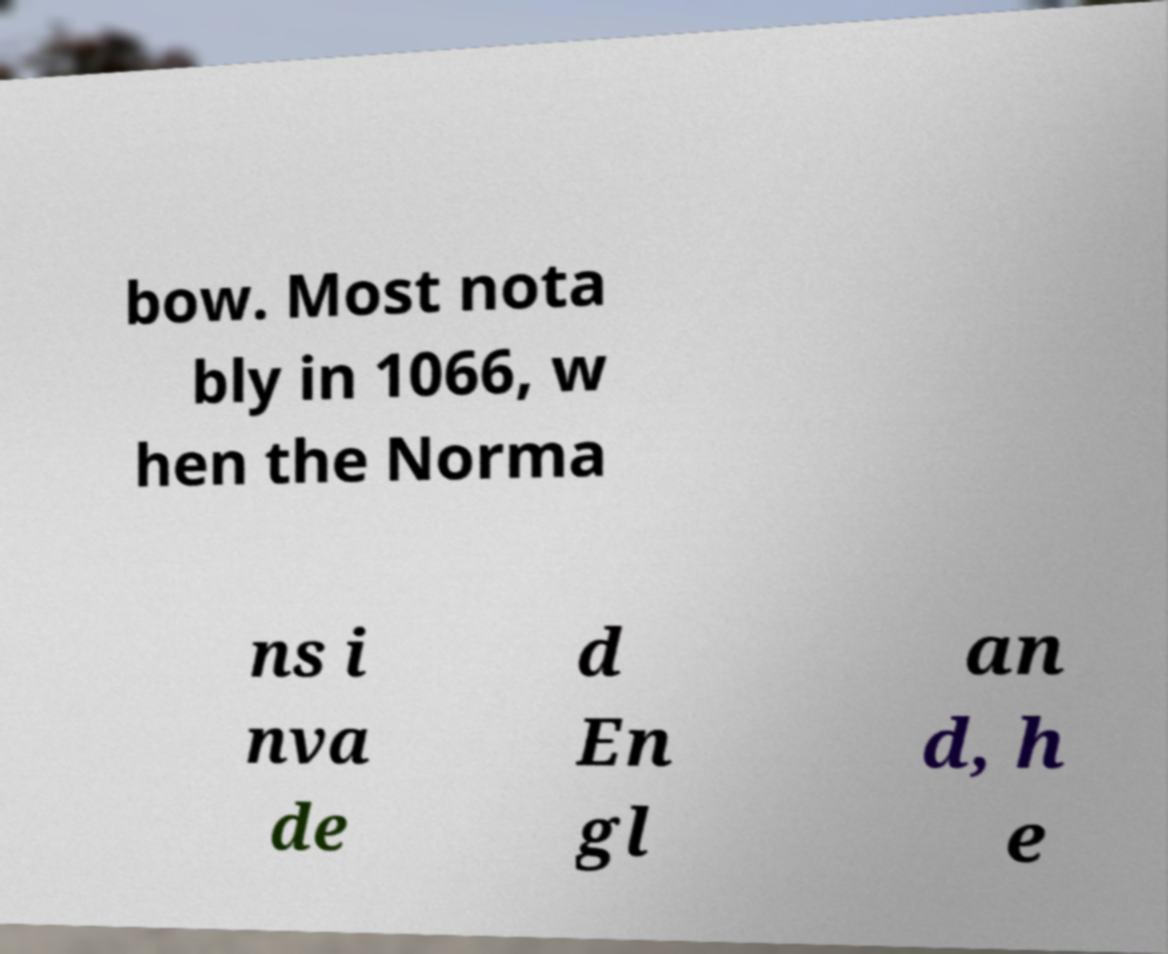For documentation purposes, I need the text within this image transcribed. Could you provide that? bow. Most nota bly in 1066, w hen the Norma ns i nva de d En gl an d, h e 